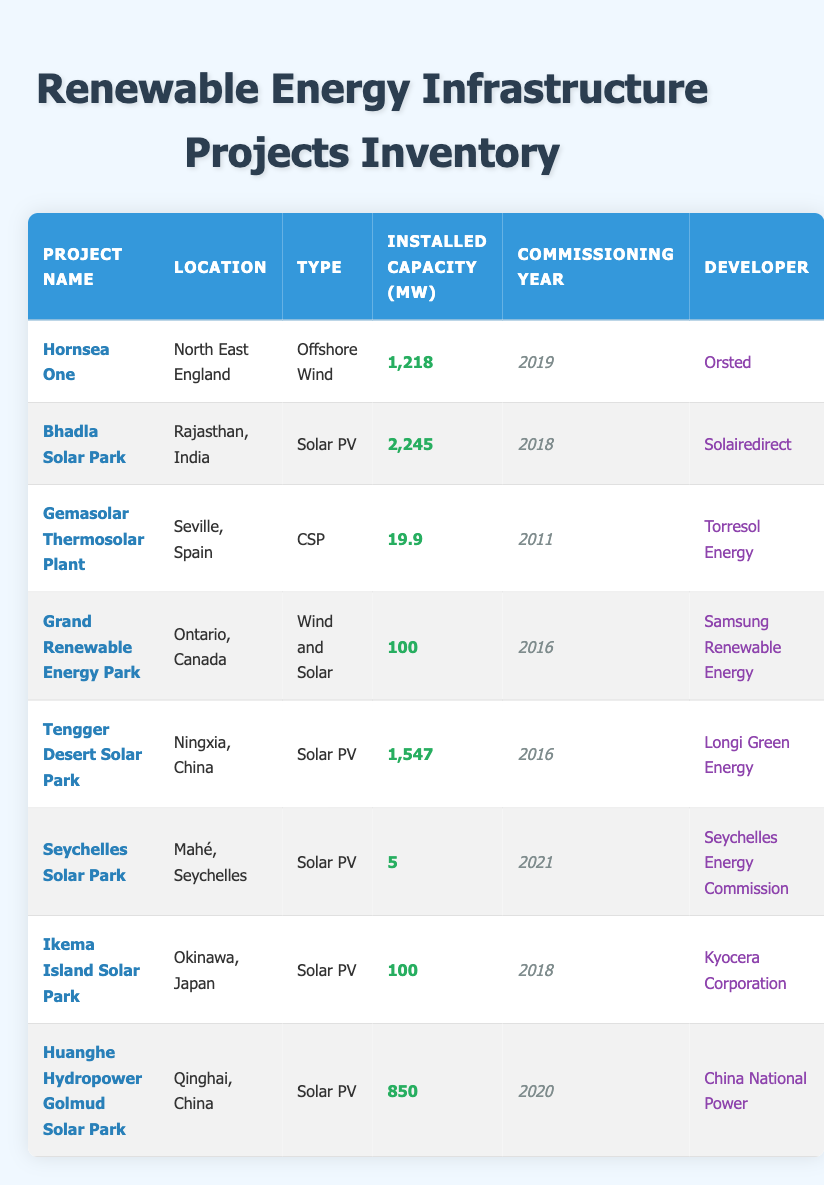What is the installed capacity of the Hornsea One project? The installed capacity of a project can be found in the "Installed Capacity (MW)" column corresponding to the "Hornsea One" entry. The value listed is 1,218 MW.
Answer: 1,218 MW Which project has the highest installed capacity? By comparing the values in the "Installed Capacity (MW)" column, the project with the highest capacity is "Bhadla Solar Park" with an installed capacity of 2,245 MW.
Answer: Bhadla Solar Park How many projects are commissioned in or after 2018? To find this, we look at the "Commissioning Year" column and count the entries from 2018 onward: Bhadla Solar Park (2018), Hornsea One (2019), Huanghe Hydropower Golmud Solar Park (2020), and Seychelles Solar Park (2021). This gives us a total of 4 projects.
Answer: 4 What is the average installed capacity of solar PV projects? The solar PV projects listed are Bhadla Solar Park (2,245 MW), Tengger Desert Solar Park (1,547 MW), Ikema Island Solar Park (100 MW), Seychelles Solar Park (5 MW), and Huanghe Hydropower Golmud Solar Park (850 MW). Adding these gives 4,747 MW. There are 5 entries, so average = 4,747 / 5 = 949.4 MW.
Answer: 949.4 MW Is the Grand Renewable Energy Park an offshore wind project? The "Grand Renewable Energy Park" is identified under the "Type" column as "Wind and Solar," which does not qualify as an offshore wind project. Thus, the answer is No.
Answer: No Which country has the most renewable energy projects listed? The entries indicate that projects from India (Bhadla Solar Park), China (Tengger Desert Solar Park, Huanghe Hydropower Golmud Solar Park), and Japan (Ikema Island Solar Park) are present. To find the count for each: India has 1, China has 2, and Japan has 1. China has the most with 2 projects.
Answer: China Are there any projects developed by Orsted? Referring to the "Developer" column, the project "Hornsea One," developed by Orsted, confirms that there is at least one project by this developer.
Answer: Yes What are the total installed capacities of projects located in China? The projects located in China include Tengger Desert Solar Park (1,547 MW) and Huanghe Hydropower Golmud Solar Park (850 MW). Adding these gives 1,547 + 850 = 2,397 MW as the total installed capacity for projects in China.
Answer: 2,397 MW 